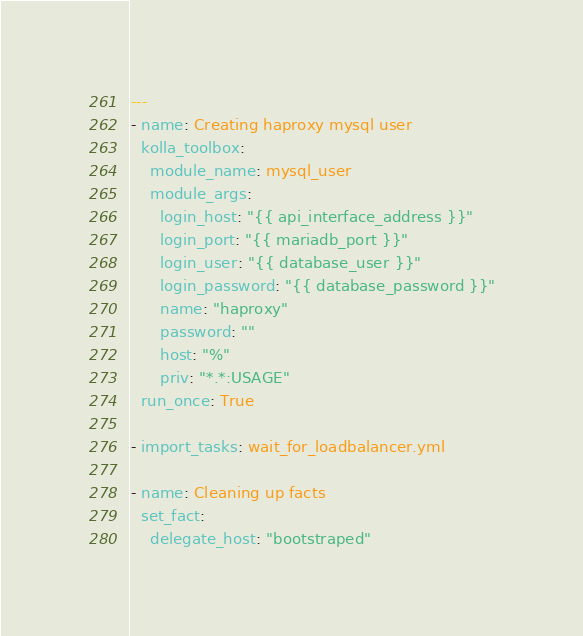Convert code to text. <code><loc_0><loc_0><loc_500><loc_500><_YAML_>---
- name: Creating haproxy mysql user
  kolla_toolbox:
    module_name: mysql_user
    module_args:
      login_host: "{{ api_interface_address }}"
      login_port: "{{ mariadb_port }}"
      login_user: "{{ database_user }}"
      login_password: "{{ database_password }}"
      name: "haproxy"
      password: ""
      host: "%"
      priv: "*.*:USAGE"
  run_once: True

- import_tasks: wait_for_loadbalancer.yml

- name: Cleaning up facts
  set_fact:
    delegate_host: "bootstraped"
</code> 